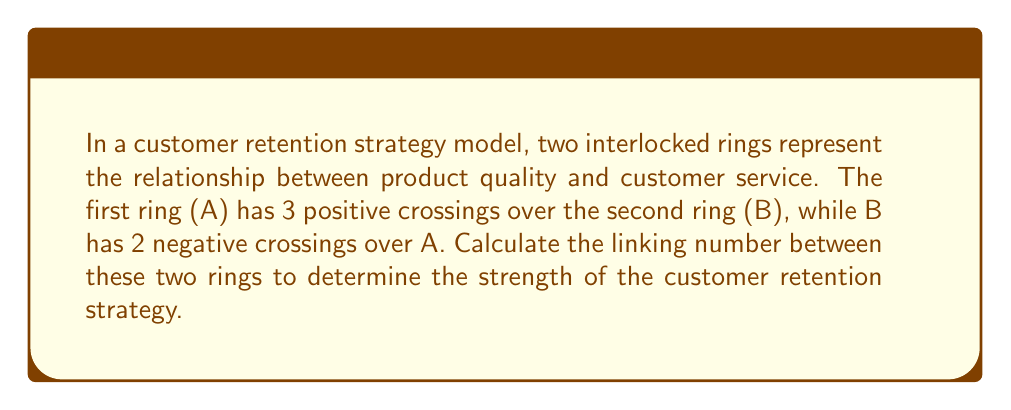Solve this math problem. To calculate the linking number between two interlocked rings, we follow these steps:

1. Identify the number of positive and negative crossings:
   Ring A has 3 positive crossings over B
   Ring B has 2 negative crossings over A

2. Calculate the linking number using the formula:
   $$ Lk(A,B) = \frac{1}{2}(\text{positive crossings} - \text{negative crossings}) $$

3. Substitute the values:
   $$ Lk(A,B) = \frac{1}{2}(3 - (-2)) $$

4. Simplify:
   $$ Lk(A,B) = \frac{1}{2}(3 + 2) = \frac{1}{2}(5) = 2.5 $$

The linking number of 2.5 indicates a strong positive correlation between product quality and customer service in the retention strategy. A higher absolute value suggests a more interconnected and effective strategy.
Answer: $Lk(A,B) = 2.5$ 